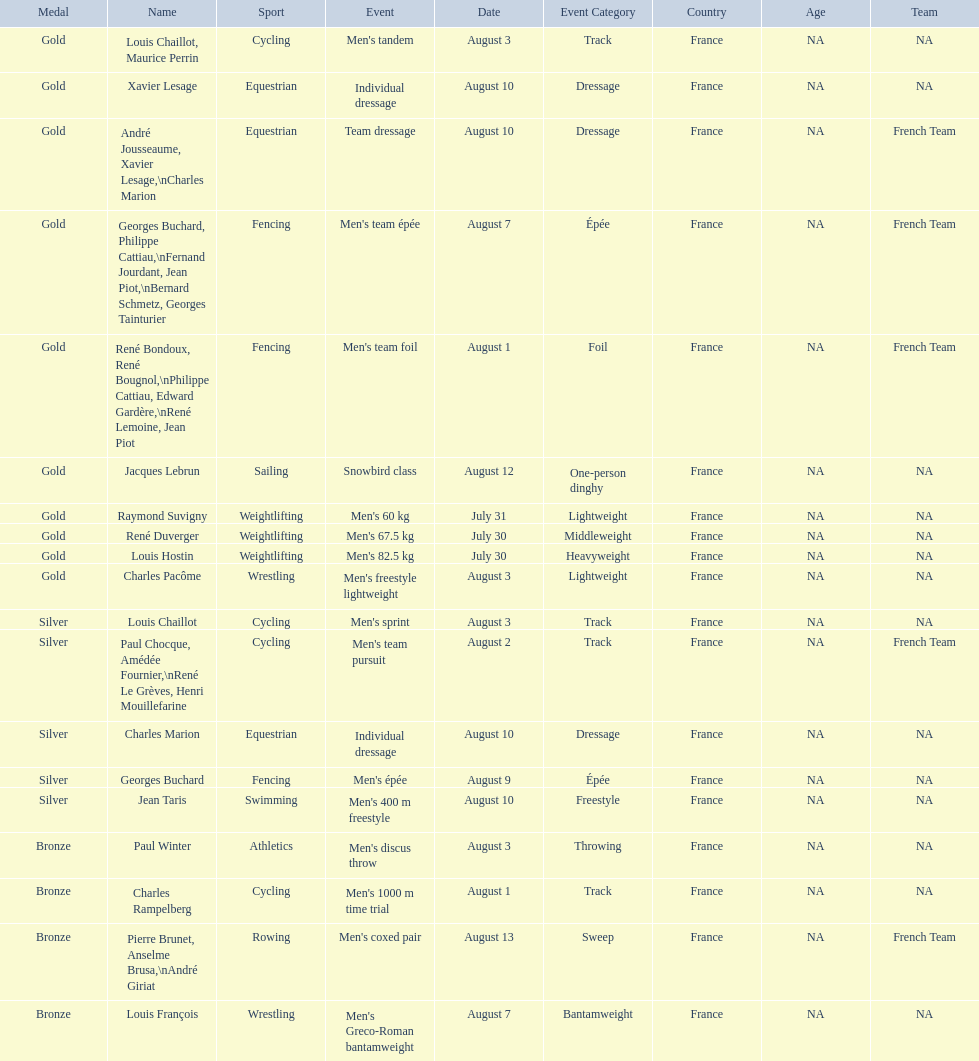How many gold medals did this country win during these olympics? 10. 